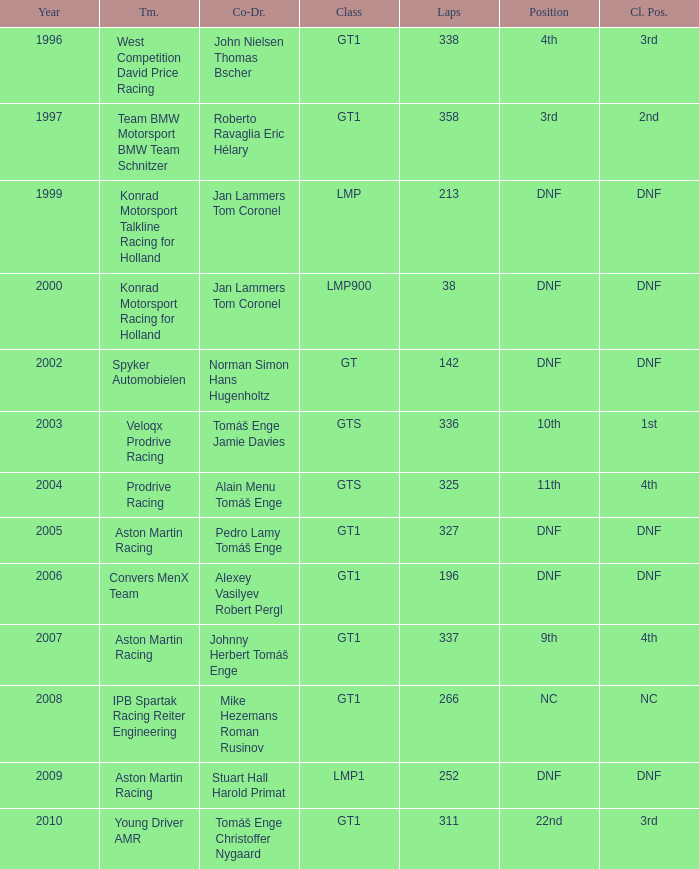In which class had 252 laps and a position of dnf? LMP1. 